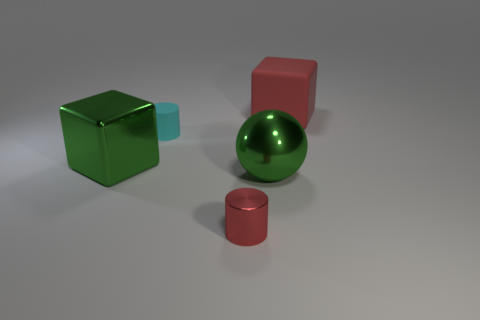How many small metal things are the same color as the large matte cube?
Give a very brief answer. 1. There is a big sphere that is the same color as the metallic cube; what is it made of?
Offer a terse response. Metal. Are there more rubber cylinders right of the red rubber block than green spheres?
Provide a succinct answer. No. Do the red matte object and the cyan object have the same shape?
Ensure brevity in your answer.  No. What number of big green balls are the same material as the tiny red thing?
Keep it short and to the point. 1. The metallic object that is the same shape as the large rubber object is what size?
Provide a succinct answer. Large. Does the cyan matte cylinder have the same size as the red block?
Offer a terse response. No. What shape is the large green thing right of the cube that is in front of the big matte thing that is on the right side of the small cyan cylinder?
Your answer should be very brief. Sphere. What is the color of the other small object that is the same shape as the small rubber object?
Your answer should be very brief. Red. There is a thing that is both to the right of the small red metallic object and in front of the small cyan matte cylinder; what size is it?
Your answer should be very brief. Large. 